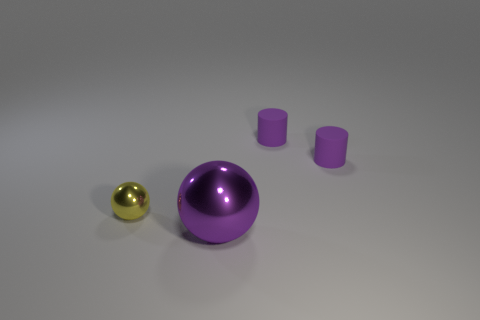Is there a tiny yellow metal thing in front of the metallic sphere that is in front of the metallic object on the left side of the large purple ball?
Your answer should be compact. No. Are the sphere that is to the right of the tiny yellow metallic thing and the ball behind the large purple ball made of the same material?
Offer a very short reply. Yes. What number of objects are small cylinders or metal spheres that are in front of the yellow metal sphere?
Provide a short and direct response. 3. What number of other large purple things are the same shape as the large thing?
Provide a succinct answer. 0. What size is the metal thing that is behind the purple object in front of the small object left of the purple sphere?
Ensure brevity in your answer.  Small. Does the tiny thing that is to the left of the purple shiny thing have the same color as the metal ball in front of the tiny metallic thing?
Provide a short and direct response. No. How many red objects are either big spheres or metal things?
Your answer should be very brief. 0. What number of purple shiny things are the same size as the purple metal ball?
Your response must be concise. 0. Do the small yellow sphere that is to the left of the large sphere and the big object have the same material?
Provide a succinct answer. Yes. Is there a purple object in front of the sphere right of the small metallic ball?
Give a very brief answer. No. 